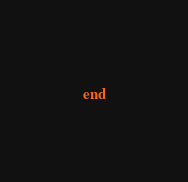Convert code to text. <code><loc_0><loc_0><loc_500><loc_500><_Ruby_>end

</code> 